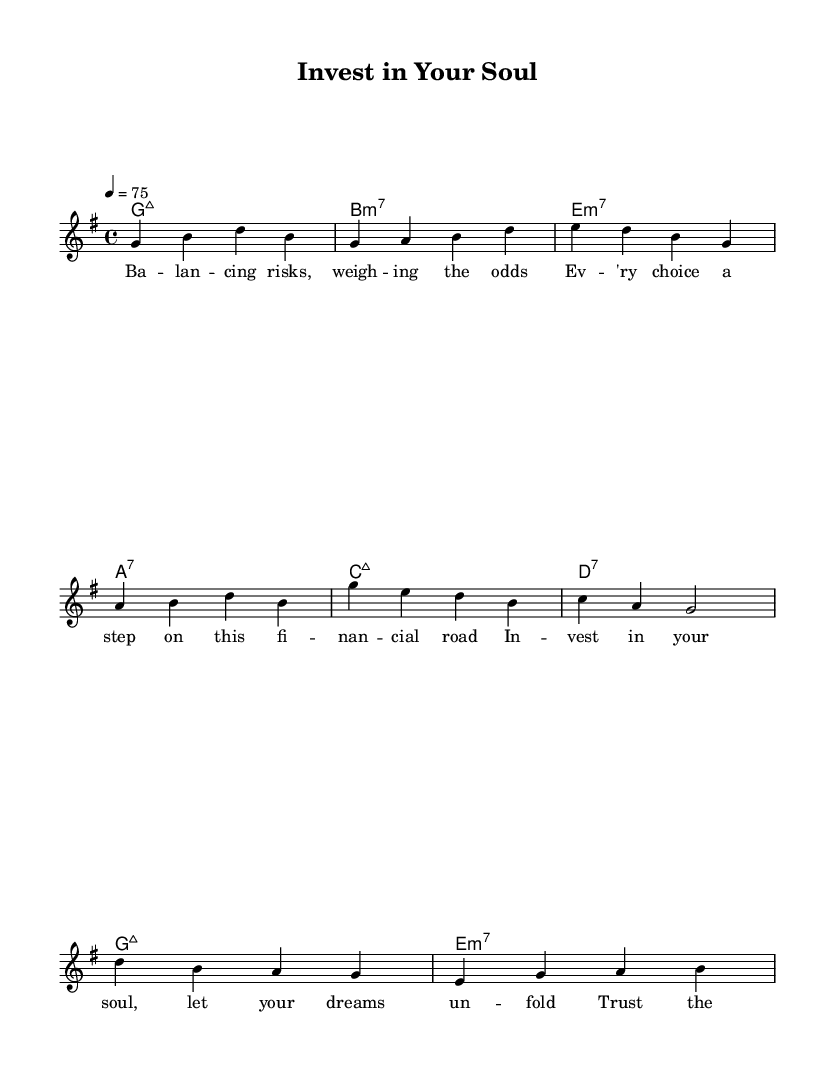What is the key signature of this music? The key signature is oriented to G major, which contains one sharp (F#). This can be identified at the beginning of the staff where the key signature is indicated.
Answer: G major What is the time signature of the piece? The time signature is 4/4, as shown at the beginning of the music staff. This means there are four beats in each measure and a quarter note receives one beat.
Answer: 4/4 What is the tempo marking of the music? The tempo marking indicates a speed of 75 beats per minute, denoted at the start of the score. It is notated as "4 = 75," which directs the performer on the pacing of the piece.
Answer: 75 What is the first chord in the piece? The first chord is G major 7, indicated in the harmonies section of the sheet music. The chord symbols listed provide necessary information about the harmonic structure, starting with G major 7.
Answer: G:maj7 How many measures are in the verse section? The verse section comprises four measures, which can be counted by looking at the notated melody and harmonies directly following each other under the verse section indication.
Answer: 4 What thematic element does the chorus focus on? The chorus emphasizes trust and growth, which are inferred from the lyrics "Trust the process, watch your wealth grow bold." The thematic content of soul music often revolves around personal empowerment and emotional expressions tied to life experiences.
Answer: Trust and growth How does the lyrical content reflect financial concepts? The lyrics in this piece discuss weighing risks and financial choices, explicitly tying emotional themes of investment to personal growth, which aligns with the soul genre's reflective nature. This blend of personal and financial undertones is common in smooth R&B-influenced soul music.
Answer: Investment and personal growth 